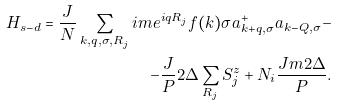<formula> <loc_0><loc_0><loc_500><loc_500>H _ { s - d } = \frac { J } { N } \sum _ { { k , q , \sigma , R } _ { j } } i m e ^ { i { q R } _ { j } } f ( { k } ) \sigma a ^ { + } _ { k + q , \sigma } a _ { k - Q , \sigma } - \\ - \frac { J } { P } 2 \Delta \sum _ { { R } _ { j } } S _ { j } ^ { z } + N _ { i } \frac { J m 2 \Delta } { P } .</formula> 